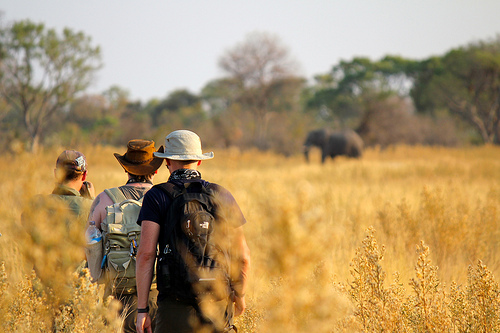Which place is it? It is a plain. 